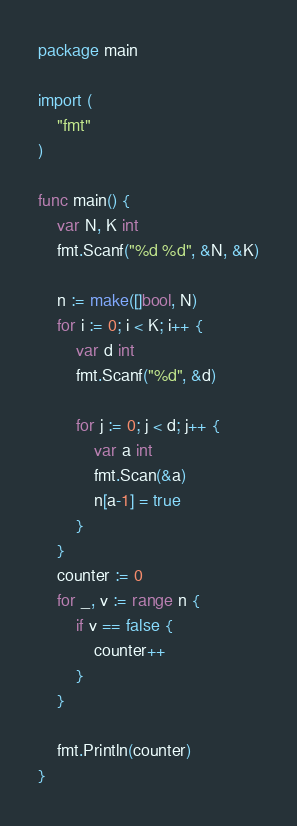<code> <loc_0><loc_0><loc_500><loc_500><_Go_>package main

import (
	"fmt"
)

func main() {
	var N, K int
	fmt.Scanf("%d %d", &N, &K)

	n := make([]bool, N)
	for i := 0; i < K; i++ {
		var d int
		fmt.Scanf("%d", &d)

		for j := 0; j < d; j++ {
			var a int
			fmt.Scan(&a)
			n[a-1] = true
		}
	}
	counter := 0
	for _, v := range n {
		if v == false {
			counter++
		}
	}

	fmt.Println(counter)
}</code> 